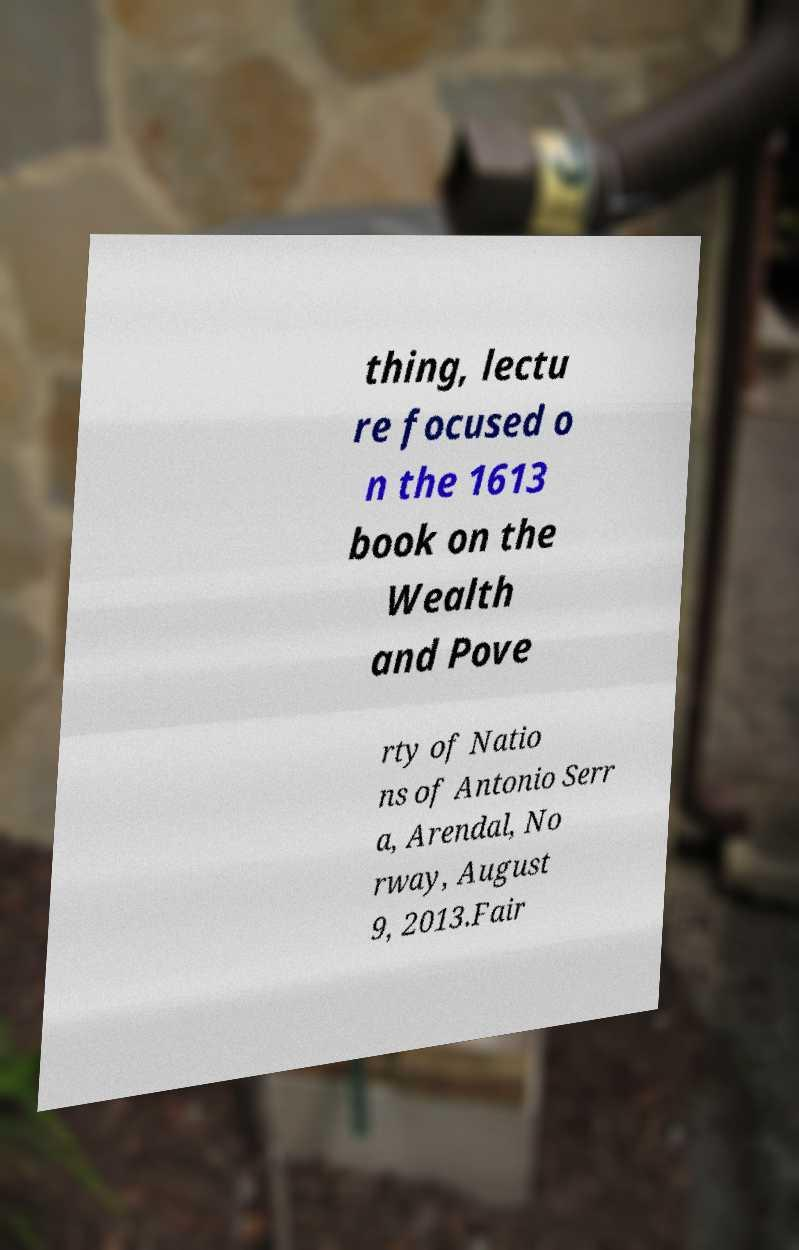I need the written content from this picture converted into text. Can you do that? thing, lectu re focused o n the 1613 book on the Wealth and Pove rty of Natio ns of Antonio Serr a, Arendal, No rway, August 9, 2013.Fair 